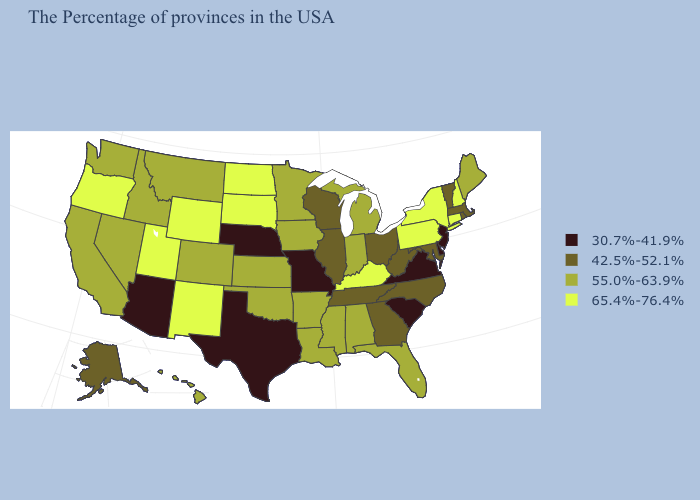Name the states that have a value in the range 30.7%-41.9%?
Short answer required. New Jersey, Delaware, Virginia, South Carolina, Missouri, Nebraska, Texas, Arizona. Among the states that border Florida , does Alabama have the highest value?
Write a very short answer. Yes. Name the states that have a value in the range 65.4%-76.4%?
Concise answer only. New Hampshire, Connecticut, New York, Pennsylvania, Kentucky, South Dakota, North Dakota, Wyoming, New Mexico, Utah, Oregon. How many symbols are there in the legend?
Give a very brief answer. 4. Does South Dakota have the highest value in the USA?
Keep it brief. Yes. Does Kentucky have the highest value in the South?
Be succinct. Yes. What is the value of Montana?
Answer briefly. 55.0%-63.9%. Name the states that have a value in the range 65.4%-76.4%?
Short answer required. New Hampshire, Connecticut, New York, Pennsylvania, Kentucky, South Dakota, North Dakota, Wyoming, New Mexico, Utah, Oregon. Which states have the lowest value in the USA?
Be succinct. New Jersey, Delaware, Virginia, South Carolina, Missouri, Nebraska, Texas, Arizona. What is the highest value in the USA?
Concise answer only. 65.4%-76.4%. Among the states that border Kentucky , does Missouri have the lowest value?
Write a very short answer. Yes. Does Kentucky have the lowest value in the USA?
Short answer required. No. What is the highest value in the USA?
Answer briefly. 65.4%-76.4%. What is the value of New York?
Give a very brief answer. 65.4%-76.4%. 